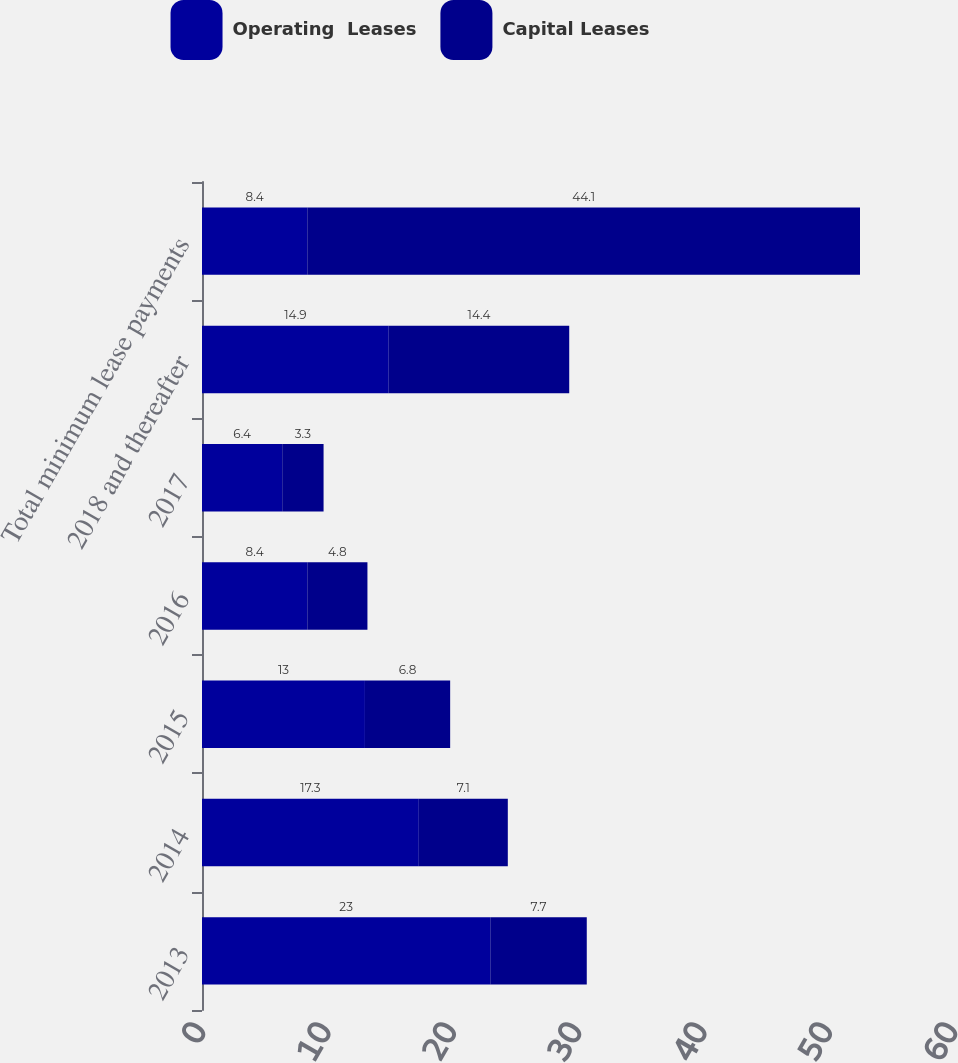<chart> <loc_0><loc_0><loc_500><loc_500><stacked_bar_chart><ecel><fcel>2013<fcel>2014<fcel>2015<fcel>2016<fcel>2017<fcel>2018 and thereafter<fcel>Total minimum lease payments<nl><fcel>Operating  Leases<fcel>23<fcel>17.3<fcel>13<fcel>8.4<fcel>6.4<fcel>14.9<fcel>8.4<nl><fcel>Capital Leases<fcel>7.7<fcel>7.1<fcel>6.8<fcel>4.8<fcel>3.3<fcel>14.4<fcel>44.1<nl></chart> 